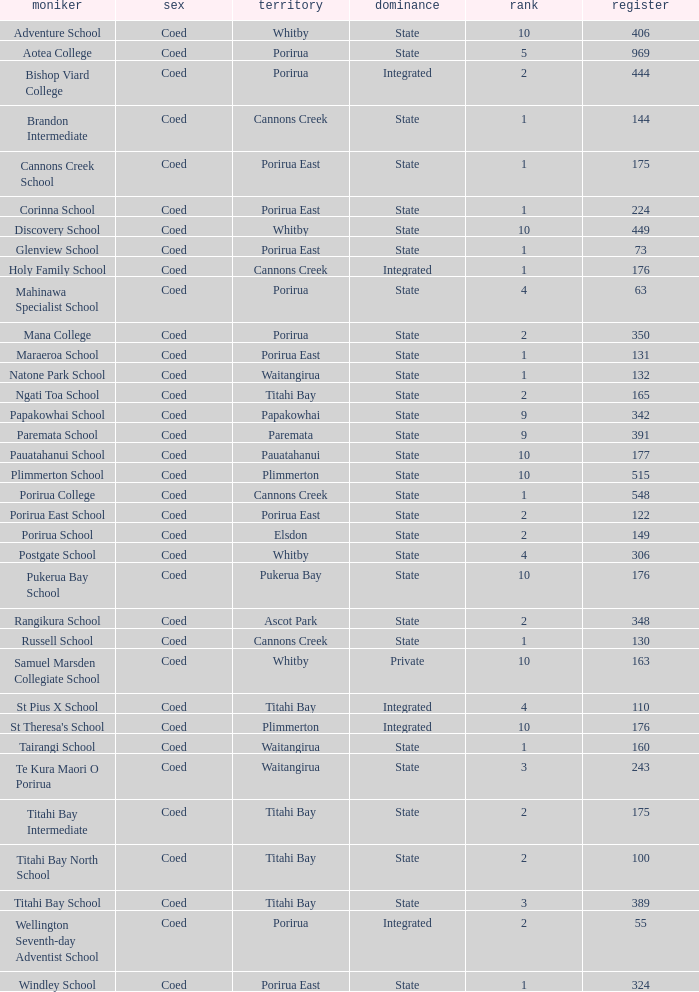Parse the full table. {'header': ['moniker', 'sex', 'territory', 'dominance', 'rank', 'register'], 'rows': [['Adventure School', 'Coed', 'Whitby', 'State', '10', '406'], ['Aotea College', 'Coed', 'Porirua', 'State', '5', '969'], ['Bishop Viard College', 'Coed', 'Porirua', 'Integrated', '2', '444'], ['Brandon Intermediate', 'Coed', 'Cannons Creek', 'State', '1', '144'], ['Cannons Creek School', 'Coed', 'Porirua East', 'State', '1', '175'], ['Corinna School', 'Coed', 'Porirua East', 'State', '1', '224'], ['Discovery School', 'Coed', 'Whitby', 'State', '10', '449'], ['Glenview School', 'Coed', 'Porirua East', 'State', '1', '73'], ['Holy Family School', 'Coed', 'Cannons Creek', 'Integrated', '1', '176'], ['Mahinawa Specialist School', 'Coed', 'Porirua', 'State', '4', '63'], ['Mana College', 'Coed', 'Porirua', 'State', '2', '350'], ['Maraeroa School', 'Coed', 'Porirua East', 'State', '1', '131'], ['Natone Park School', 'Coed', 'Waitangirua', 'State', '1', '132'], ['Ngati Toa School', 'Coed', 'Titahi Bay', 'State', '2', '165'], ['Papakowhai School', 'Coed', 'Papakowhai', 'State', '9', '342'], ['Paremata School', 'Coed', 'Paremata', 'State', '9', '391'], ['Pauatahanui School', 'Coed', 'Pauatahanui', 'State', '10', '177'], ['Plimmerton School', 'Coed', 'Plimmerton', 'State', '10', '515'], ['Porirua College', 'Coed', 'Cannons Creek', 'State', '1', '548'], ['Porirua East School', 'Coed', 'Porirua East', 'State', '2', '122'], ['Porirua School', 'Coed', 'Elsdon', 'State', '2', '149'], ['Postgate School', 'Coed', 'Whitby', 'State', '4', '306'], ['Pukerua Bay School', 'Coed', 'Pukerua Bay', 'State', '10', '176'], ['Rangikura School', 'Coed', 'Ascot Park', 'State', '2', '348'], ['Russell School', 'Coed', 'Cannons Creek', 'State', '1', '130'], ['Samuel Marsden Collegiate School', 'Coed', 'Whitby', 'Private', '10', '163'], ['St Pius X School', 'Coed', 'Titahi Bay', 'Integrated', '4', '110'], ["St Theresa's School", 'Coed', 'Plimmerton', 'Integrated', '10', '176'], ['Tairangi School', 'Coed', 'Waitangirua', 'State', '1', '160'], ['Te Kura Maori O Porirua', 'Coed', 'Waitangirua', 'State', '3', '243'], ['Titahi Bay Intermediate', 'Coed', 'Titahi Bay', 'State', '2', '175'], ['Titahi Bay North School', 'Coed', 'Titahi Bay', 'State', '2', '100'], ['Titahi Bay School', 'Coed', 'Titahi Bay', 'State', '3', '389'], ['Wellington Seventh-day Adventist School', 'Coed', 'Porirua', 'Integrated', '2', '55'], ['Windley School', 'Coed', 'Porirua East', 'State', '1', '324']]} How many students are there at bishop viard college (an integrated college) with a decile rating above 1? 1.0. 